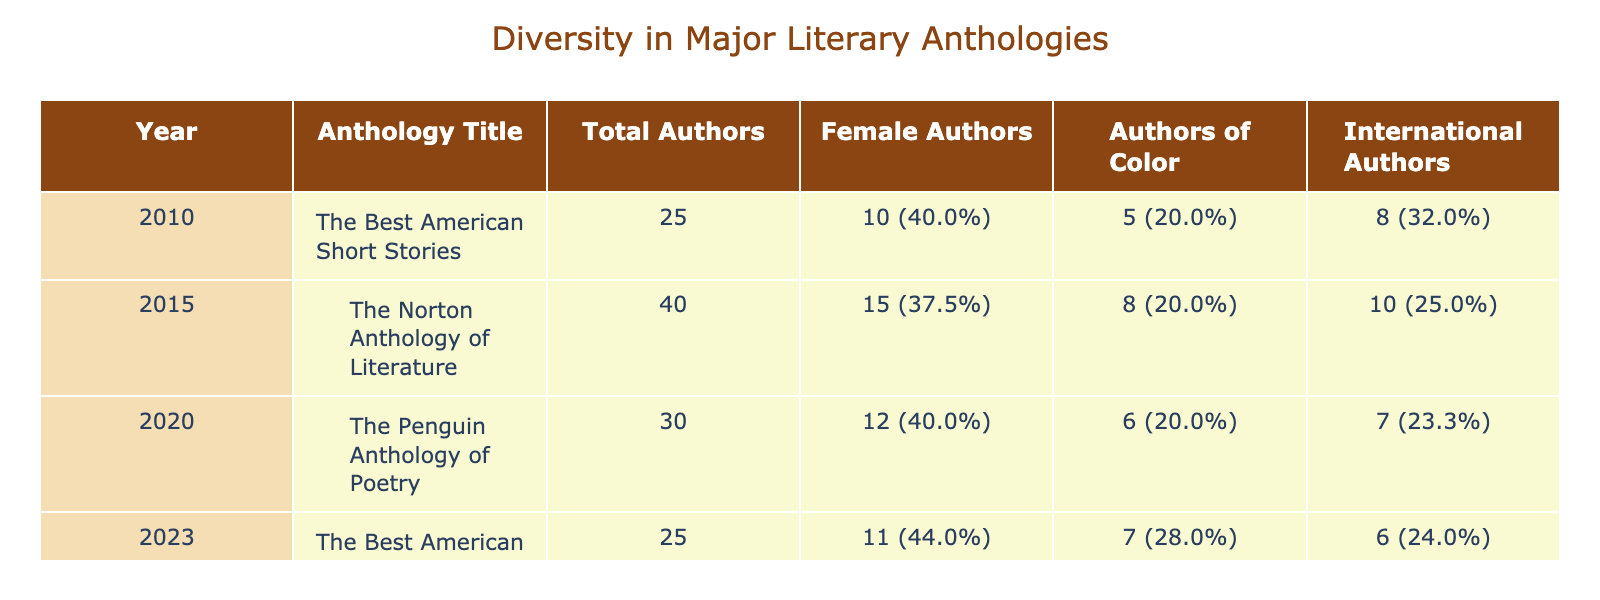What is the total number of authors in the 2020 anthology? The table lists the total number of authors for each anthology by year. For the year 2020, under the "Total Authors" column, it shows the number as 30.
Answer: 30 How many female authors were included in the 2015 anthology? Looking at the 2015 row in the "Number of Female Authors" column, it clearly shows that 15 female authors were included in that anthology.
Answer: 15 Which anthology had the highest percentage of female authors? To determine this, we can look at the percentage values in the "% Female" column. The values are 40.0% for 2015, 43.3% for 2020, 44.0% for 2023, and 40.0% for 2010. Therefore, the 2023 anthology had the highest percentage of female authors at 44.0%.
Answer: 2023 What is the total number of authors of color across all anthologies? We can find the total by adding the "Number of Authors of Color" across all rows: 5 (2010) + 8 (2015) + 6 (2020) + 7 (2023) = 26.
Answer: 26 Did the 2010 anthology have more international authors than the 2023 anthology? In the "Number of International Authors" column, the 2010 anthology lists 8 international authors, while the 2023 anthology lists 6. Therefore, the 2010 anthology had more international authors than the 2023 anthology.
Answer: Yes What is the average number of total authors across the four anthologies? To find the average, add the "Total Authors" values: 25 (2010) + 40 (2015) + 30 (2020) + 25 (2023) = 120. Divide by the number of anthologies (4): 120 / 4 = 30.
Answer: 30 Which year shows a decrease in the number of total authors compared to the previous year? Looking at the years 2010, 2015, 2020, and 2023, the number of authors decreased from 40 (2015) to 30 (2020). Therefore, the year 2020 shows a decrease in the total number of authors.
Answer: 2020 What percentage of authors in the 2023 anthology were authors of color? In the 2023 row, the "Number of Authors of Color" is 7, and the "Total Authors" is 25. To get the percentage, calculate (7/25) * 100 = 28.0%.
Answer: 28.0% 